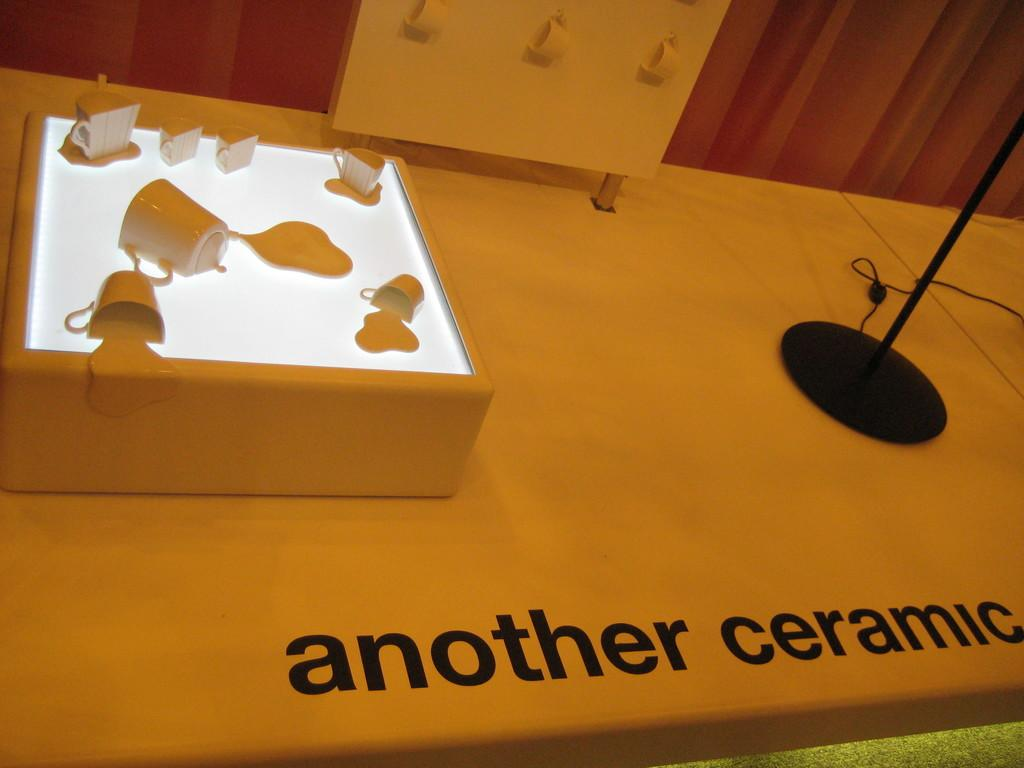What can be found on the platform in the image? There are objects, a stand, a cable, and cups hanging on a board on the platform. What is the purpose of the stand on the platform? The purpose of the stand is not explicitly mentioned, but it could be used to hold or display items. What is the cable used for on the platform? The purpose of the cable is not explicitly mentioned, but it could be used for electrical connections or other purposes. What is written on the platform? There is a text written on the platform, but its content is not specified. What can be seen in the background of the image? The wall is visible in the background. What type of scent can be detected in the image? There is no mention of any scent in the image, so it cannot be determined from the image. What shape is the army formation in the image? There is no army or formation present in the image; it features objects on a platform with a stand, cable, and cups hanging on a board. 